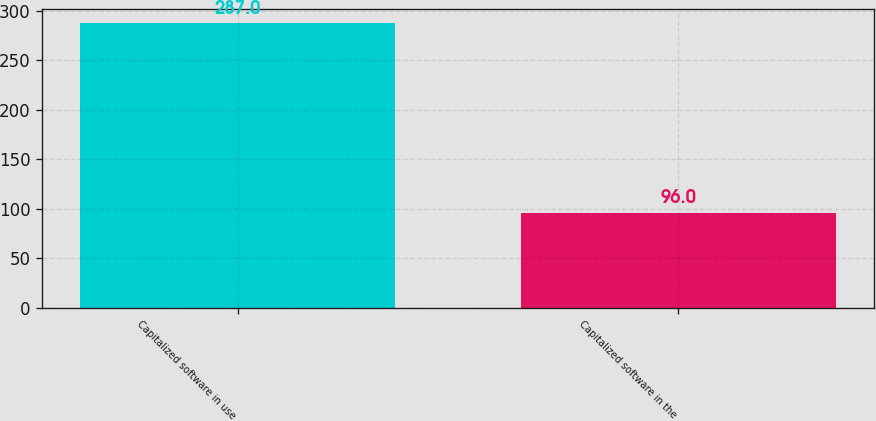Convert chart. <chart><loc_0><loc_0><loc_500><loc_500><bar_chart><fcel>Capitalized software in use<fcel>Capitalized software in the<nl><fcel>287<fcel>96<nl></chart> 